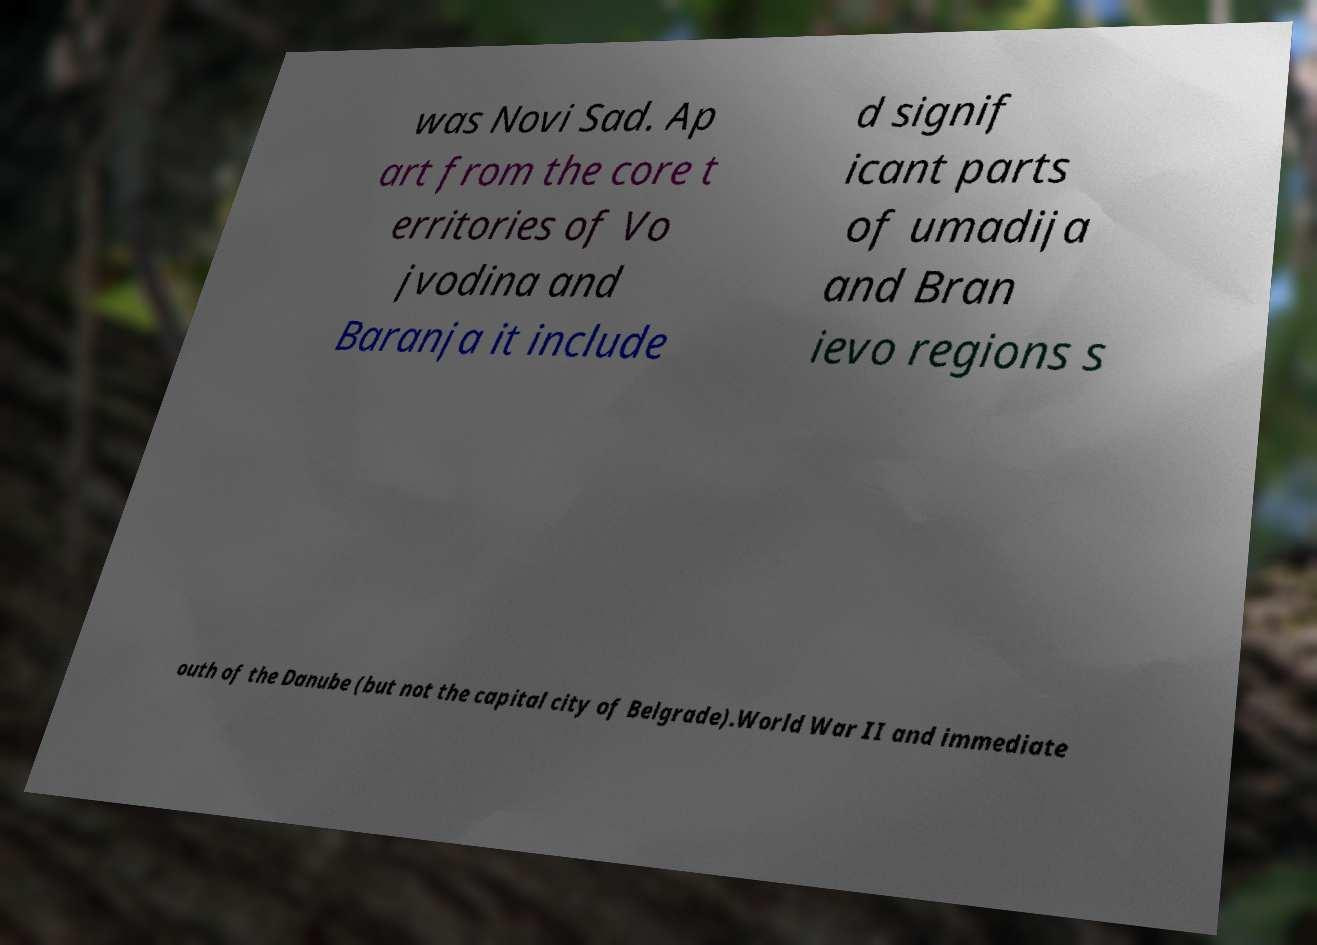There's text embedded in this image that I need extracted. Can you transcribe it verbatim? was Novi Sad. Ap art from the core t erritories of Vo jvodina and Baranja it include d signif icant parts of umadija and Bran ievo regions s outh of the Danube (but not the capital city of Belgrade).World War II and immediate 